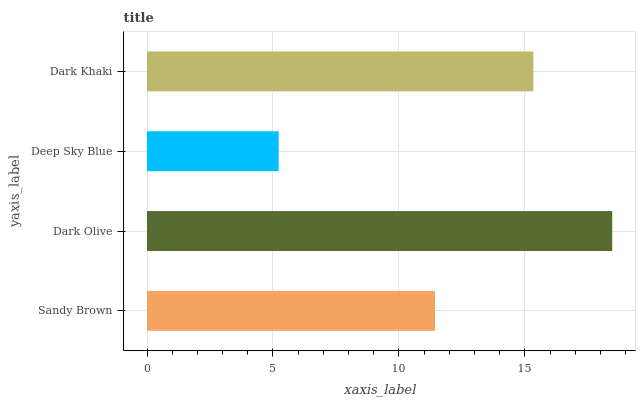Is Deep Sky Blue the minimum?
Answer yes or no. Yes. Is Dark Olive the maximum?
Answer yes or no. Yes. Is Dark Olive the minimum?
Answer yes or no. No. Is Deep Sky Blue the maximum?
Answer yes or no. No. Is Dark Olive greater than Deep Sky Blue?
Answer yes or no. Yes. Is Deep Sky Blue less than Dark Olive?
Answer yes or no. Yes. Is Deep Sky Blue greater than Dark Olive?
Answer yes or no. No. Is Dark Olive less than Deep Sky Blue?
Answer yes or no. No. Is Dark Khaki the high median?
Answer yes or no. Yes. Is Sandy Brown the low median?
Answer yes or no. Yes. Is Dark Olive the high median?
Answer yes or no. No. Is Dark Olive the low median?
Answer yes or no. No. 